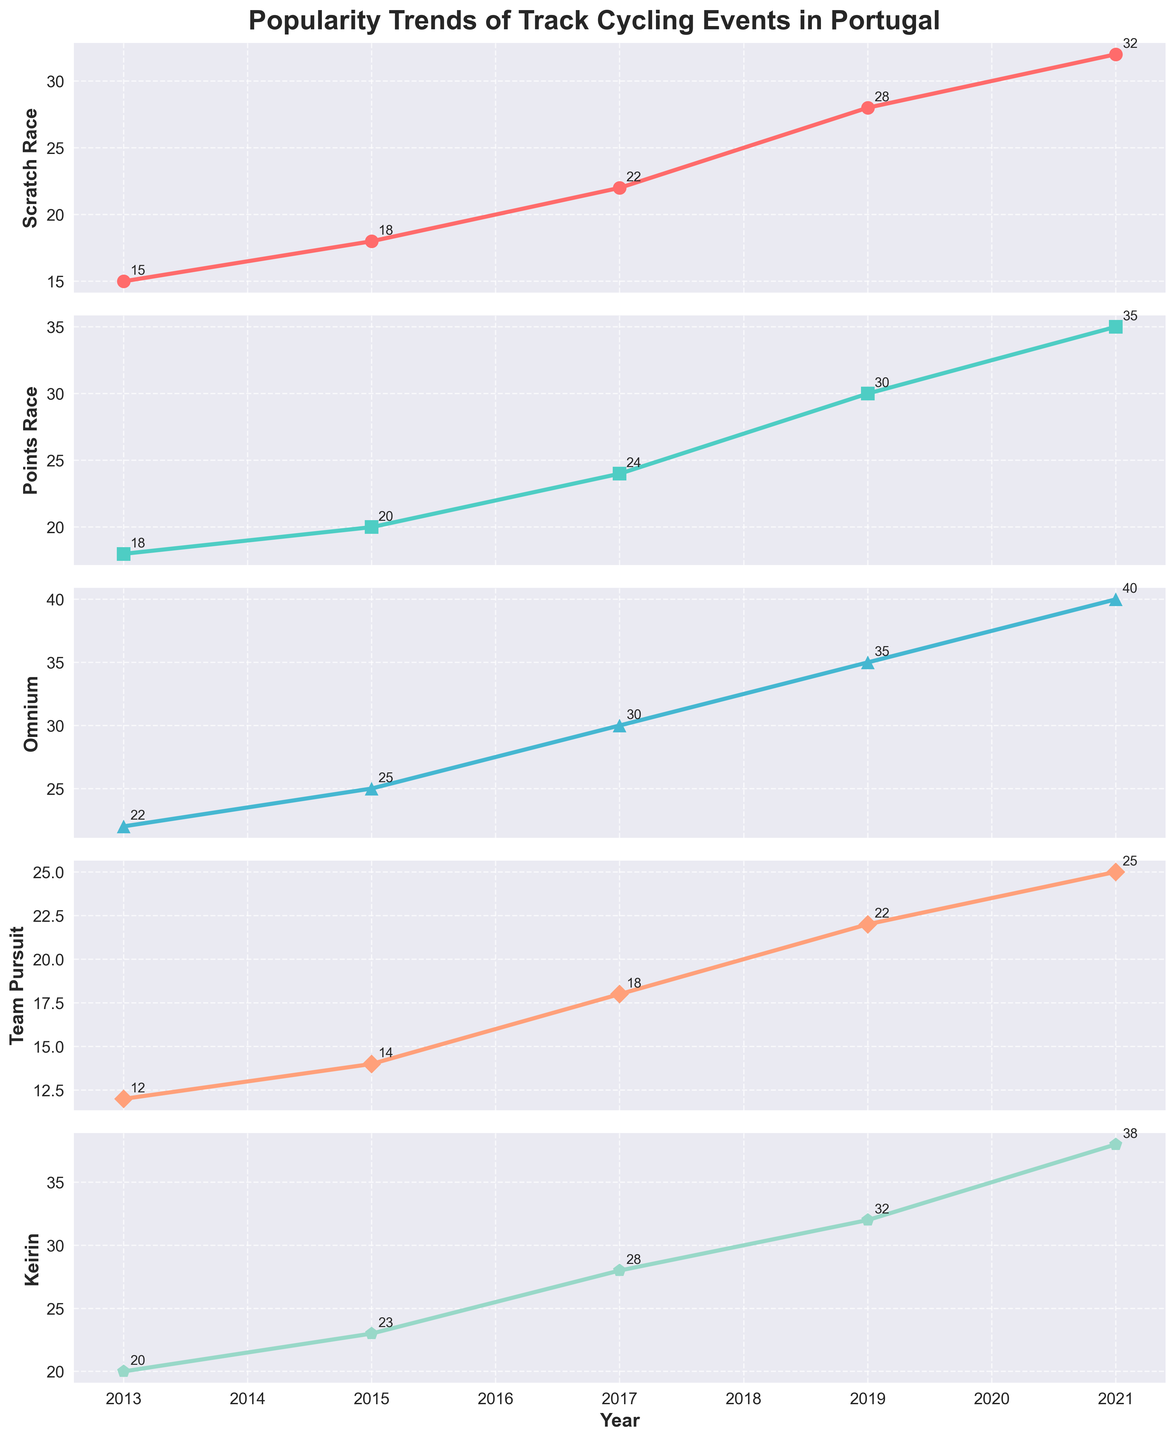Which event was the most popular in 2021? Look at the data column for 2021 and identify the event with the highest value.
Answer: Keirin How many years of data are shown in the plot? Count the number of unique years listed along the x-axis.
Answer: 5 Which event had the least popularity in 2013? Look at the data column for 2013 and identify the event with the lowest value.
Answer: Team Pursuit What's the average popularity of the Scratch Race over the years shown? Sum the values of the Scratch Race for all years and divide by the number of years: (15 + 18 + 22 + 28 + 32) / 5.
Answer: 23 In which year did the Points Race and Omnium have the same popularity? Compare the popularity values for Points Race and Omnium in each year and find the year where both have the same value.
Answer: No year What is the difference in popularity between the Scratch Race and the Keirin in 2019? Subtract the Scratch Race value from the Keirin value for the year 2019: 32 - 28.
Answer: 4 Did any event's popularity decline in any of the years depicted? Examine each event's popularity values year over year to check for any decline.
Answer: No Which event showed the highest increase in popularity from 2013 to 2021? Calculate the increase for each event from 2013 to 2021 and identify the highest: 
Scractch Race: 32 - 15 = 17
Points Race: 35 - 18 = 17
Omnium: 40 - 22 = 18
Team Pursuit: 25 - 12 = 13
Keirin: 38 - 20 = 18.
Answer: Omnium and Keirin When did Team Pursuit reach a popularity of 18? Look at the data column for Team Pursuit and identify the year where it reached 18.
Answer: 2017 Which event had a steady increase in popularity without any fluctuations? Analyze the trend lines for each event to check for consistent increases year by year without any dips.
Answer: Keirin 